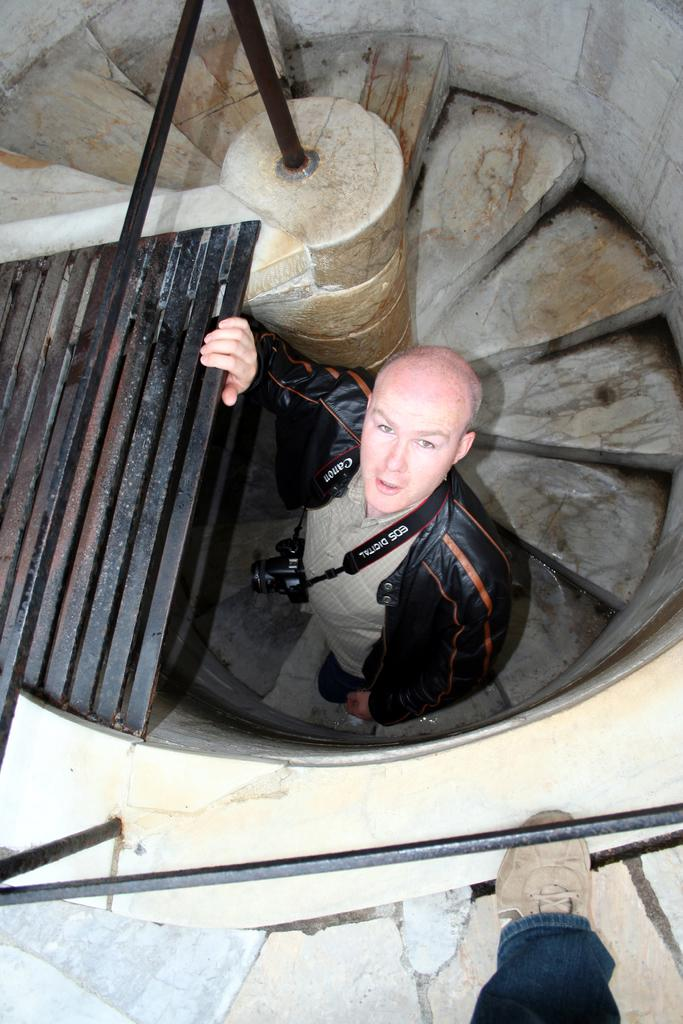What part of a person can be seen in the image? There is a person's leg in the image. What object is present in the image that is used for capturing images? There is a camera in the image. What type of structural elements are visible in the image? There are rods, walls, and steps in the image. What is the position of the person in the image? There is a man standing in the image. What grade does the person in the image have in their muscle development? There is no information about the person's muscle development or grade in the image, as it only shows a leg, a camera, rods, walls, steps, and a man standing. 